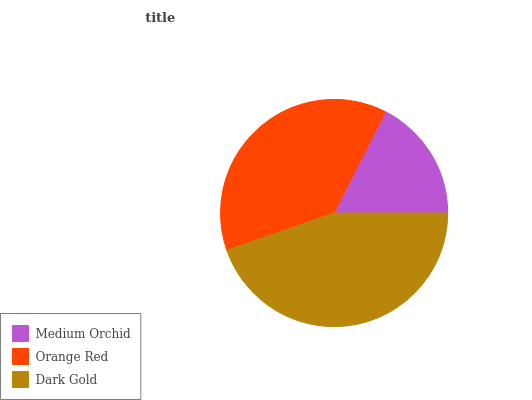Is Medium Orchid the minimum?
Answer yes or no. Yes. Is Dark Gold the maximum?
Answer yes or no. Yes. Is Orange Red the minimum?
Answer yes or no. No. Is Orange Red the maximum?
Answer yes or no. No. Is Orange Red greater than Medium Orchid?
Answer yes or no. Yes. Is Medium Orchid less than Orange Red?
Answer yes or no. Yes. Is Medium Orchid greater than Orange Red?
Answer yes or no. No. Is Orange Red less than Medium Orchid?
Answer yes or no. No. Is Orange Red the high median?
Answer yes or no. Yes. Is Orange Red the low median?
Answer yes or no. Yes. Is Medium Orchid the high median?
Answer yes or no. No. Is Dark Gold the low median?
Answer yes or no. No. 